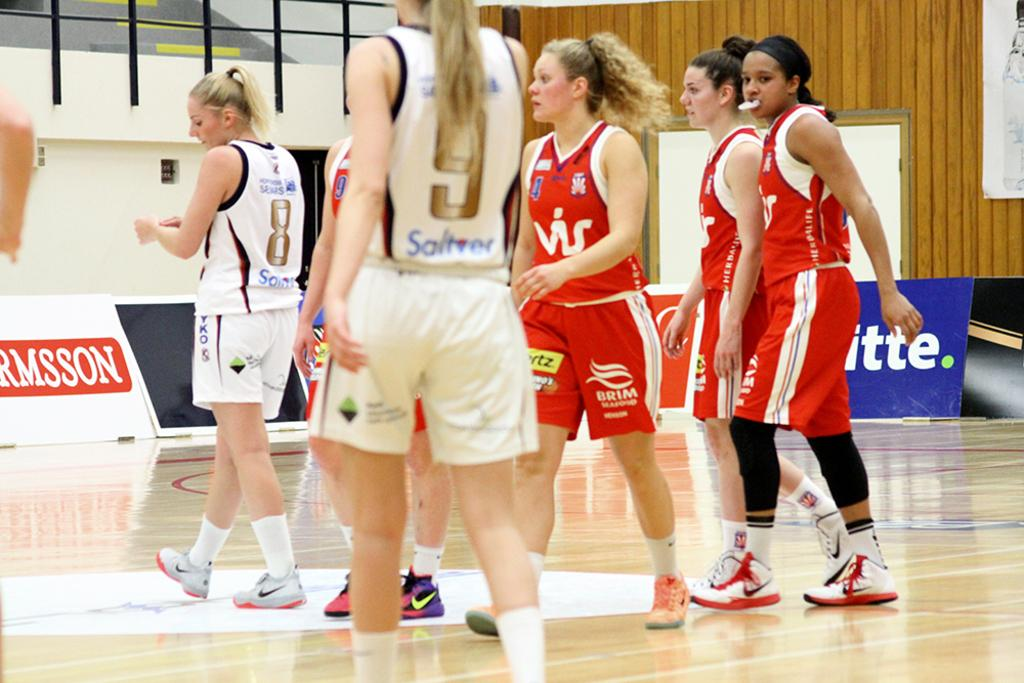Provide a one-sentence caption for the provided image. A bunch of women playing an indoor sport; one of them is wearing a number 8 shirt. 